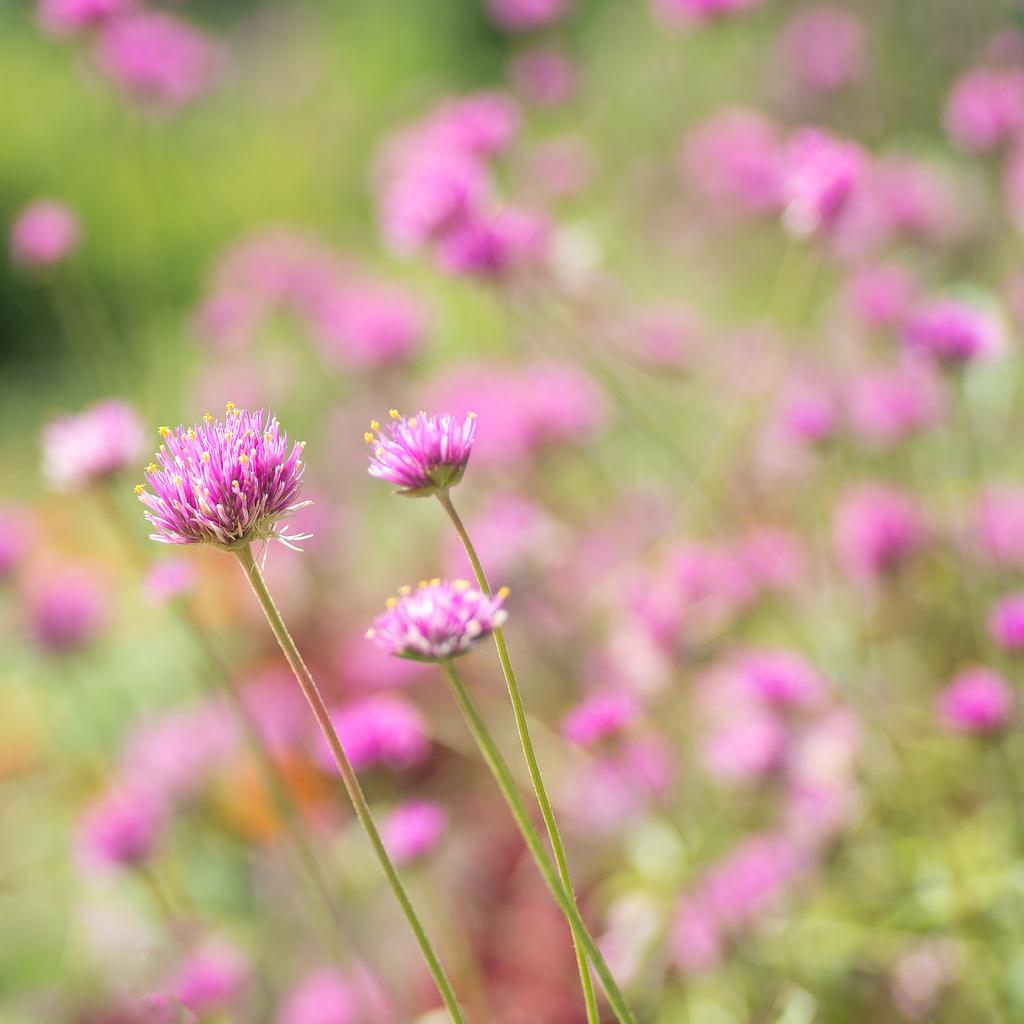What type of plants are in the image? There are flowers in the image. What color are the flowers? The flowers are pink in color. Can you describe any part of the flowers besides the petals? Yes, there is a stem of the flower visible in the image. What is the appearance of the background in the image? The background of the image is blurred. What type of cork can be seen in the image? There is no cork present in the image. 